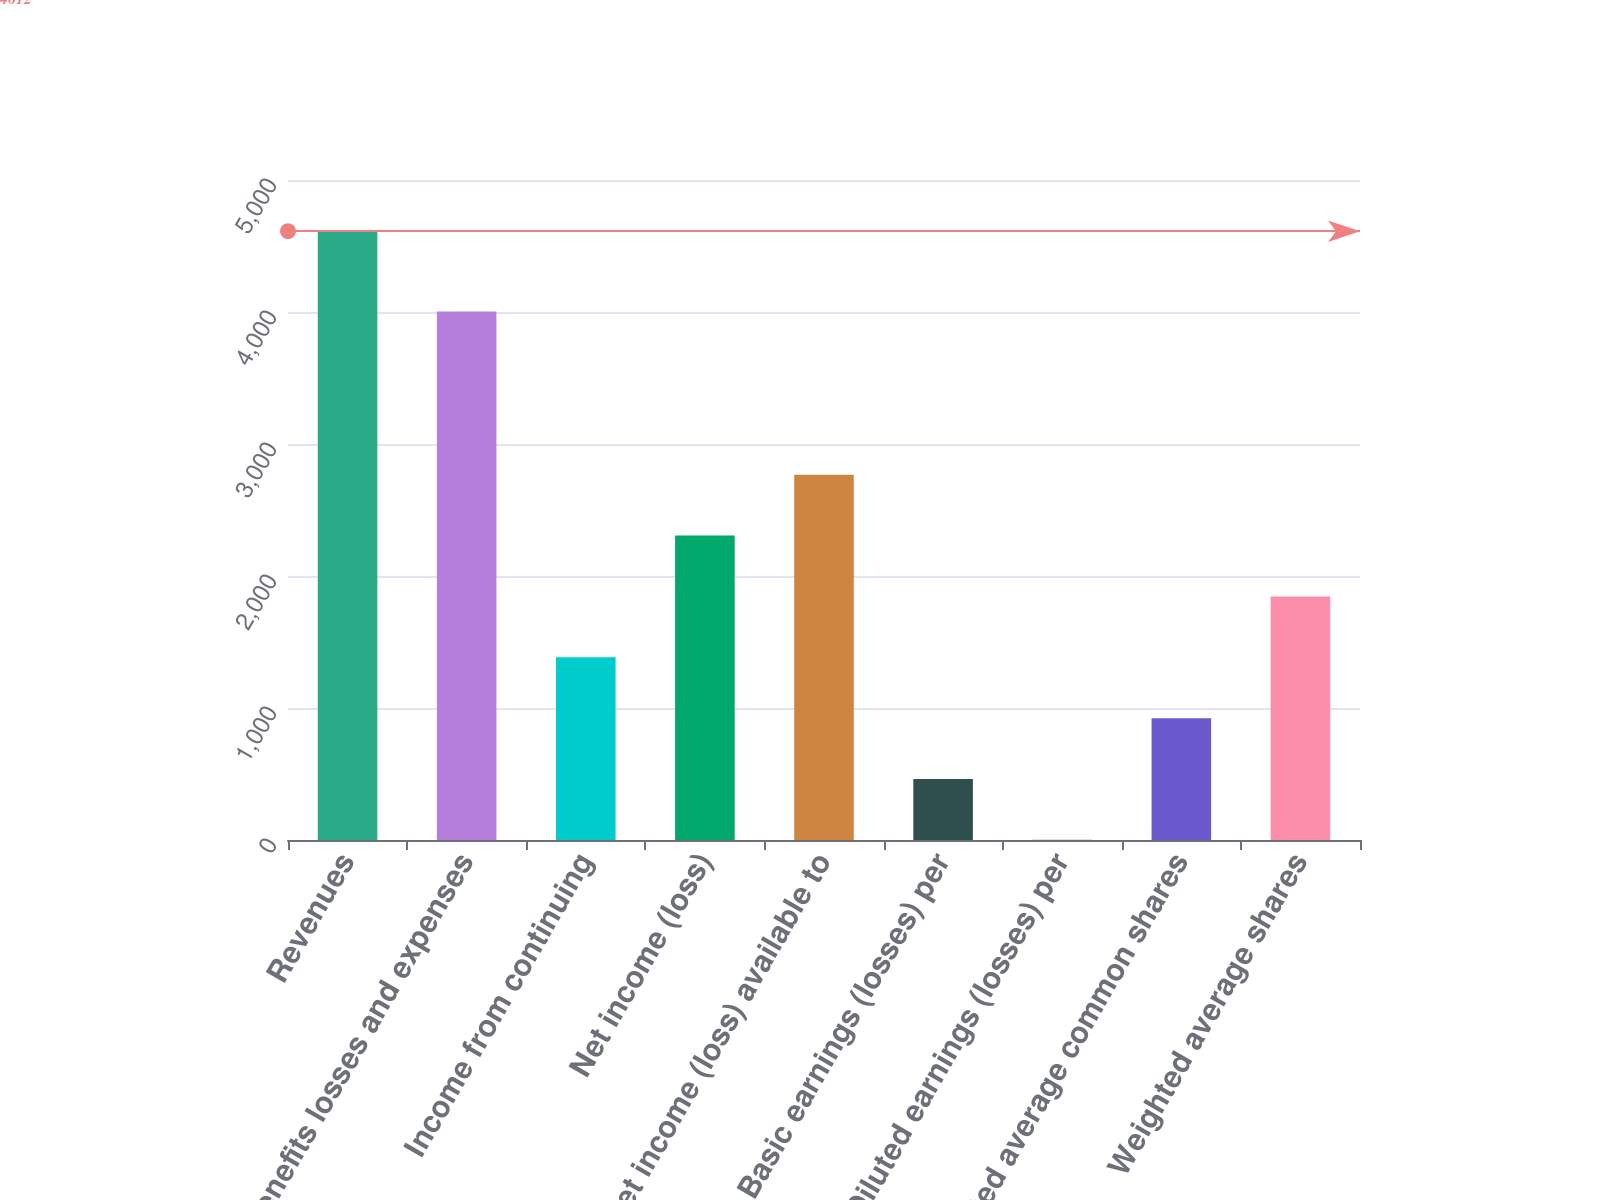<chart> <loc_0><loc_0><loc_500><loc_500><bar_chart><fcel>Revenues<fcel>Benefits losses and expenses<fcel>Income from continuing<fcel>Net income (loss)<fcel>Net income (loss) available to<fcel>Basic earnings (losses) per<fcel>Diluted earnings (losses) per<fcel>Weighted average common shares<fcel>Weighted average shares<nl><fcel>4612<fcel>4003<fcel>1384.33<fcel>2306.53<fcel>2767.63<fcel>462.13<fcel>1.03<fcel>923.23<fcel>1845.43<nl></chart> 